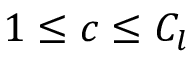<formula> <loc_0><loc_0><loc_500><loc_500>1 \leq c \leq C _ { l }</formula> 